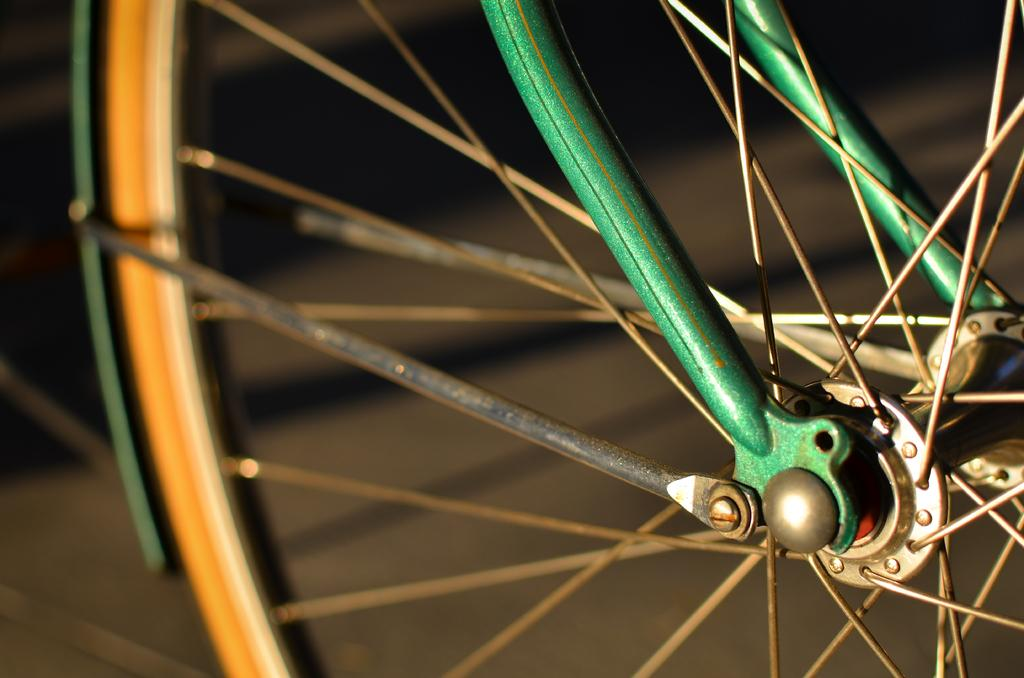Where was the image taken? The image was taken outdoors. What can be seen at the bottom of the image? There is a road at the bottom of the image. What object is located on the right side of the image? There is a bicycle wheel on the right side of the image. What type of poison is being used to cook the oatmeal in the image? There is no oatmeal or poison present in the image. What type of bread can be seen on the left side of the image? There is no bread present in the image. 